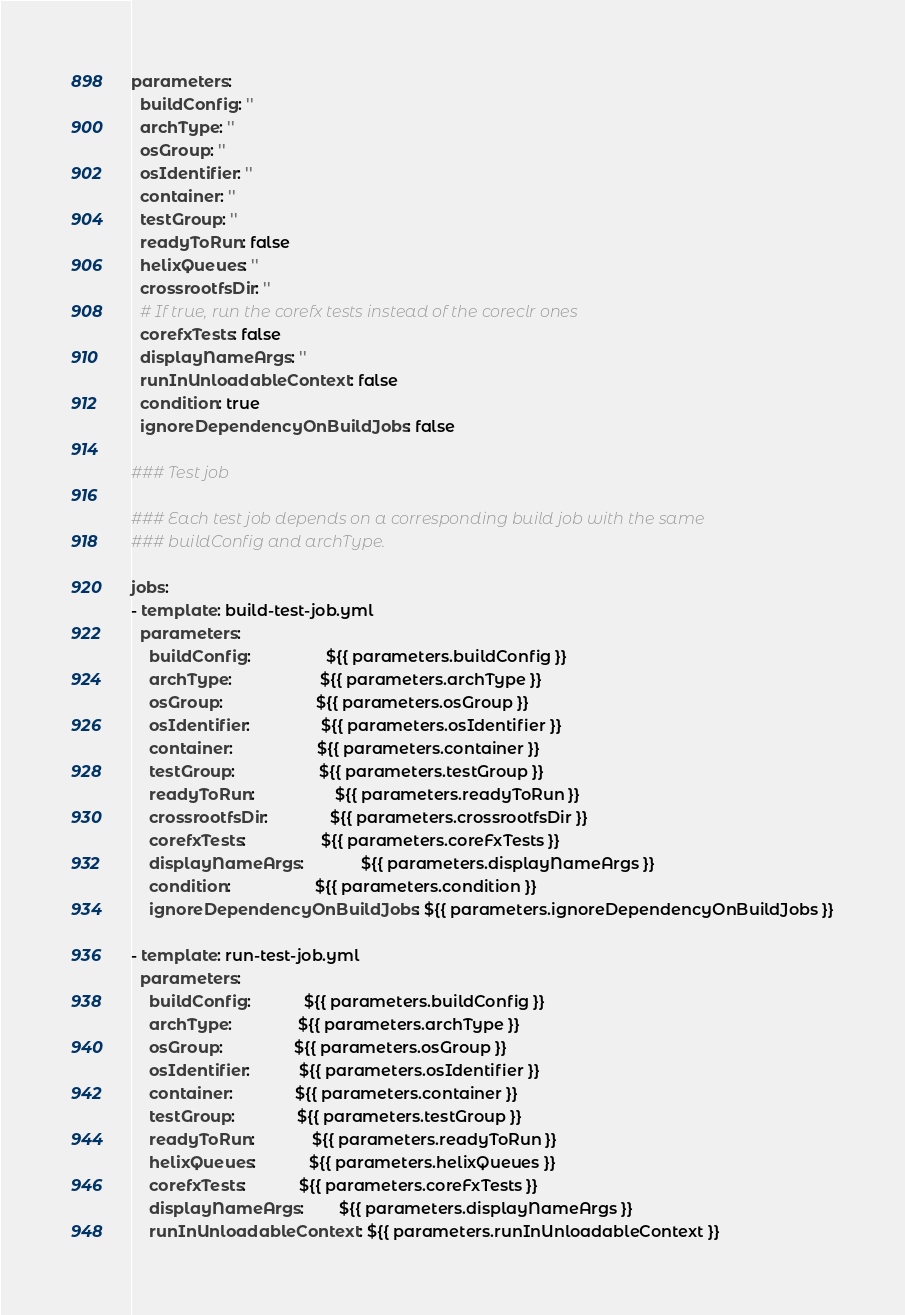<code> <loc_0><loc_0><loc_500><loc_500><_YAML_>parameters:
  buildConfig: ''
  archType: ''
  osGroup: ''
  osIdentifier: ''
  container: ''
  testGroup: ''
  readyToRun: false
  helixQueues: ''
  crossrootfsDir: ''
  # If true, run the corefx tests instead of the coreclr ones
  corefxTests: false
  displayNameArgs: ''
  runInUnloadableContext: false
  condition: true
  ignoreDependencyOnBuildJobs: false

### Test job

### Each test job depends on a corresponding build job with the same
### buildConfig and archType.

jobs:
- template: build-test-job.yml
  parameters:
    buildConfig:                 ${{ parameters.buildConfig }}
    archType:                    ${{ parameters.archType }}
    osGroup:                     ${{ parameters.osGroup }}
    osIdentifier:                ${{ parameters.osIdentifier }}
    container:                   ${{ parameters.container }}
    testGroup:                   ${{ parameters.testGroup }}
    readyToRun:                  ${{ parameters.readyToRun }}
    crossrootfsDir:              ${{ parameters.crossrootfsDir }}
    corefxTests:                 ${{ parameters.coreFxTests }}
    displayNameArgs:             ${{ parameters.displayNameArgs }}
    condition:                   ${{ parameters.condition }}
    ignoreDependencyOnBuildJobs: ${{ parameters.ignoreDependencyOnBuildJobs }}

- template: run-test-job.yml
  parameters:
    buildConfig:            ${{ parameters.buildConfig }}
    archType:               ${{ parameters.archType }}
    osGroup:                ${{ parameters.osGroup }}
    osIdentifier:           ${{ parameters.osIdentifier }}
    container:              ${{ parameters.container }}
    testGroup:              ${{ parameters.testGroup }}
    readyToRun:             ${{ parameters.readyToRun }}
    helixQueues:            ${{ parameters.helixQueues }}
    corefxTests:            ${{ parameters.coreFxTests }}
    displayNameArgs:        ${{ parameters.displayNameArgs }}
    runInUnloadableContext: ${{ parameters.runInUnloadableContext }}
</code> 